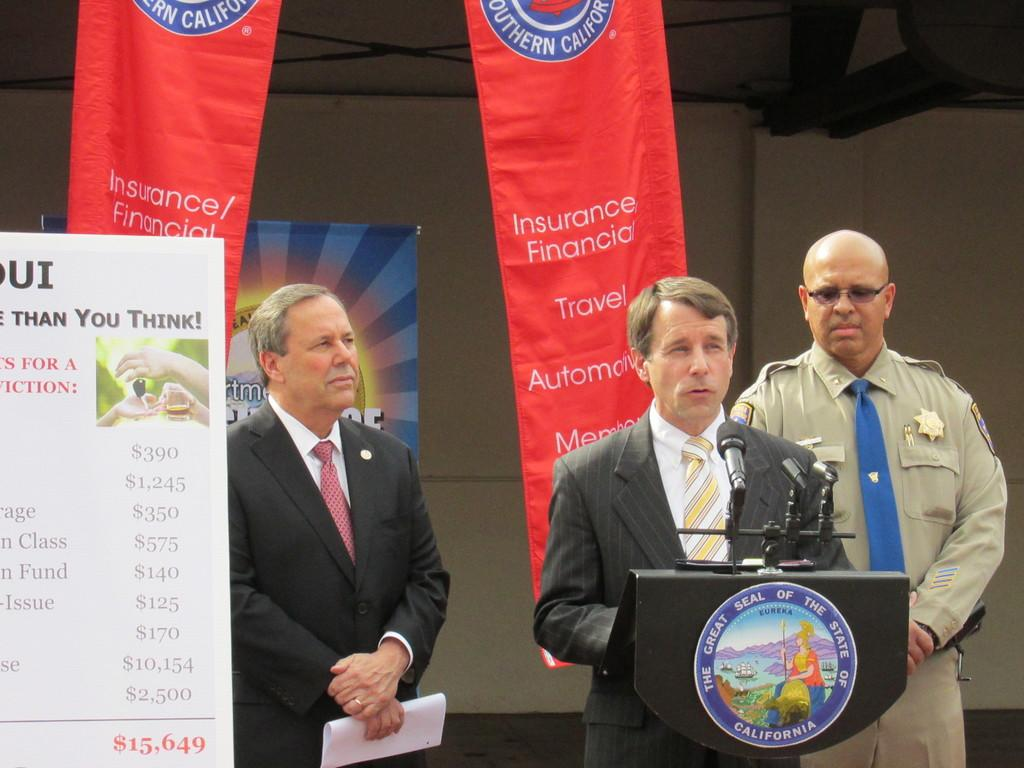What is the main subject of the image? The main subject of the image is men standing. Can you describe the position of one of the men in the image? One of the men is at a lectern. What type of signage can be seen in the image? Advertisement boards are present in the image. What type of structure is visible in the image? There are walls visible in the image. How many boys are playing with the zebra in the image? There are no boys or zebras present in the image. What type of advice does the dad give to the men in the image? There is no dad present in the image, and therefore no advice can be given. 